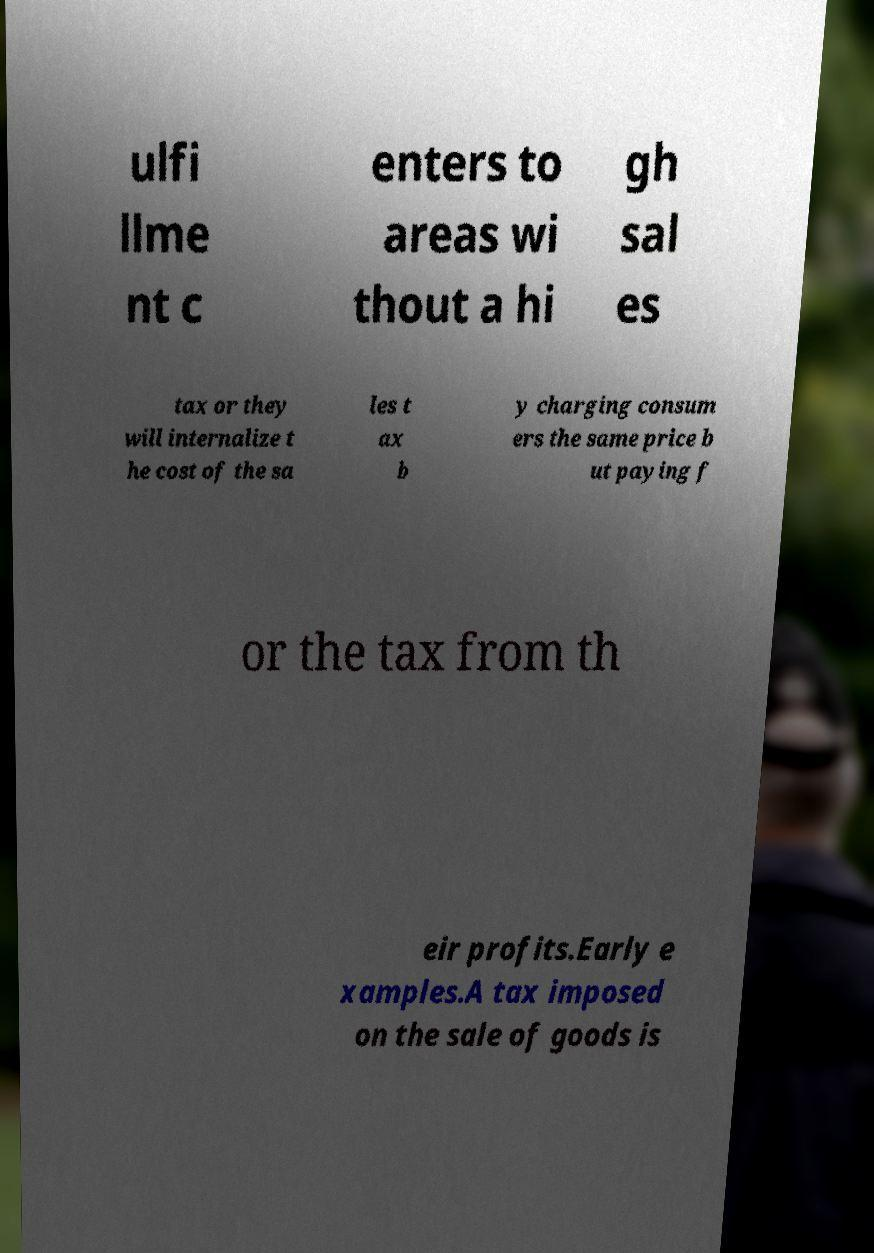Can you accurately transcribe the text from the provided image for me? ulfi llme nt c enters to areas wi thout a hi gh sal es tax or they will internalize t he cost of the sa les t ax b y charging consum ers the same price b ut paying f or the tax from th eir profits.Early e xamples.A tax imposed on the sale of goods is 